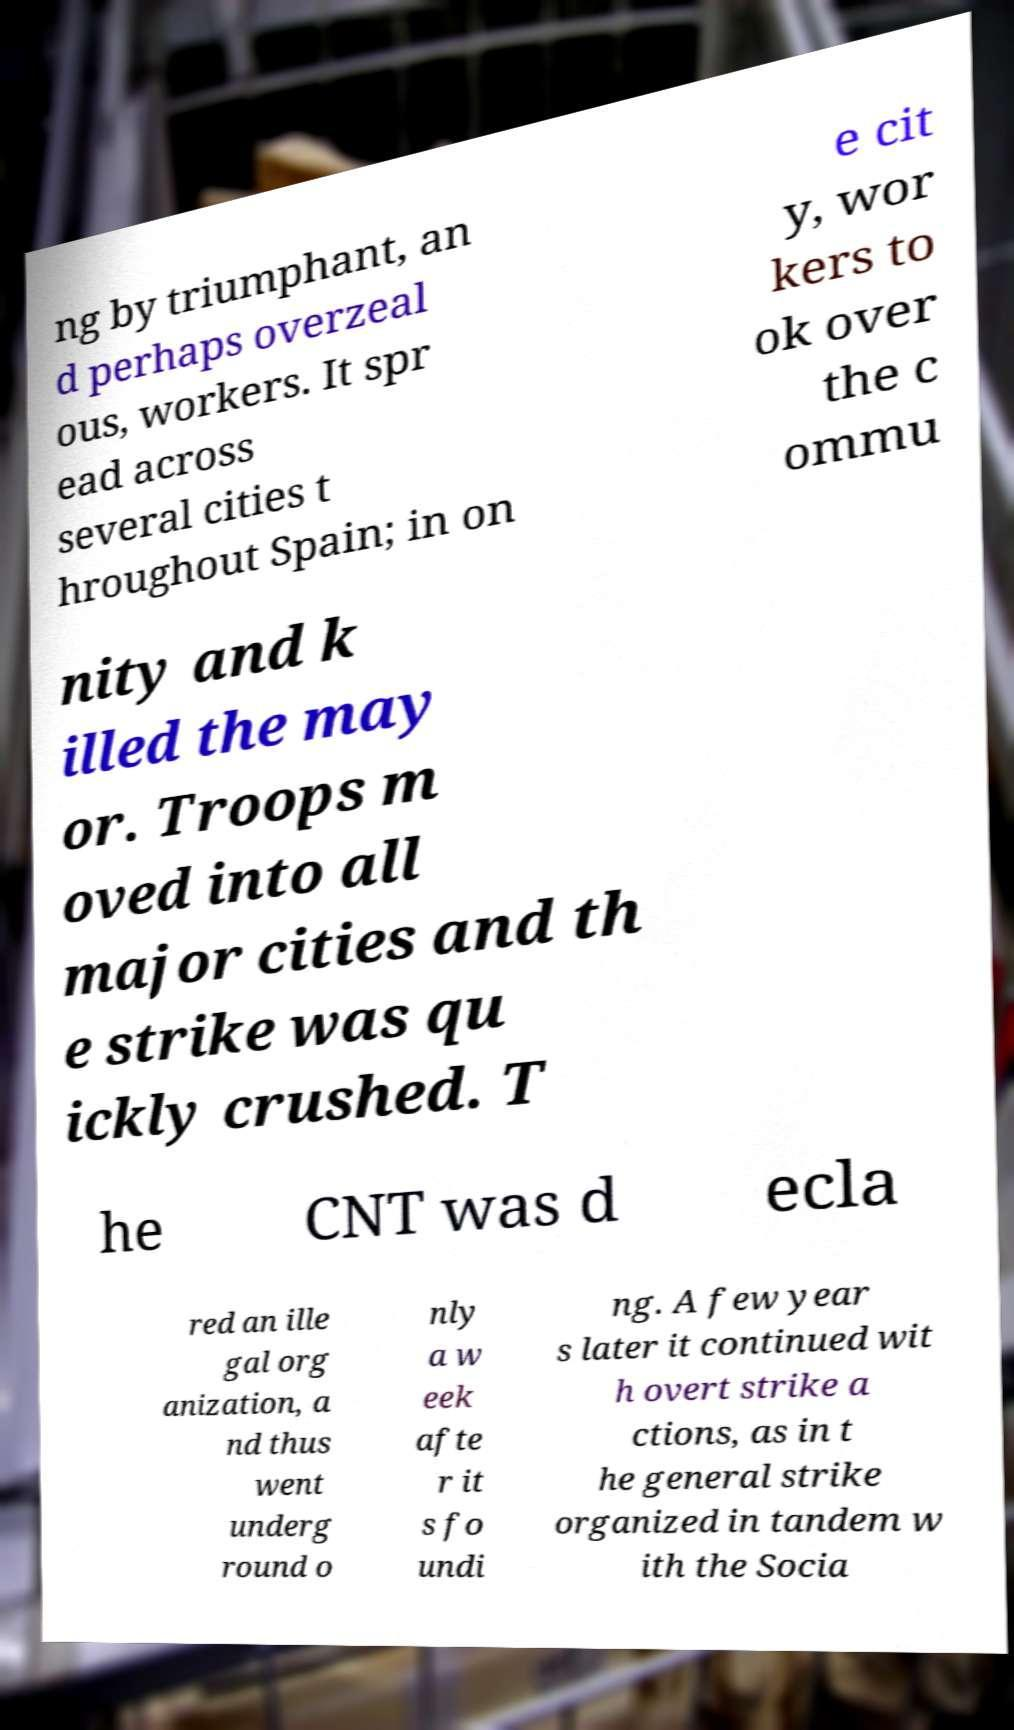There's text embedded in this image that I need extracted. Can you transcribe it verbatim? ng by triumphant, an d perhaps overzeal ous, workers. It spr ead across several cities t hroughout Spain; in on e cit y, wor kers to ok over the c ommu nity and k illed the may or. Troops m oved into all major cities and th e strike was qu ickly crushed. T he CNT was d ecla red an ille gal org anization, a nd thus went underg round o nly a w eek afte r it s fo undi ng. A few year s later it continued wit h overt strike a ctions, as in t he general strike organized in tandem w ith the Socia 